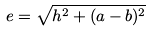<formula> <loc_0><loc_0><loc_500><loc_500>e = \sqrt { h ^ { 2 } + ( a - b ) ^ { 2 } }</formula> 